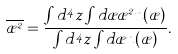<formula> <loc_0><loc_0><loc_500><loc_500>\overline { \rho ^ { 2 } } = \frac { \int d ^ { 4 } z \int d \rho \rho ^ { 2 } n ( \rho ) } { \int d ^ { 4 } z \int d \rho n ( \rho ) } .</formula> 